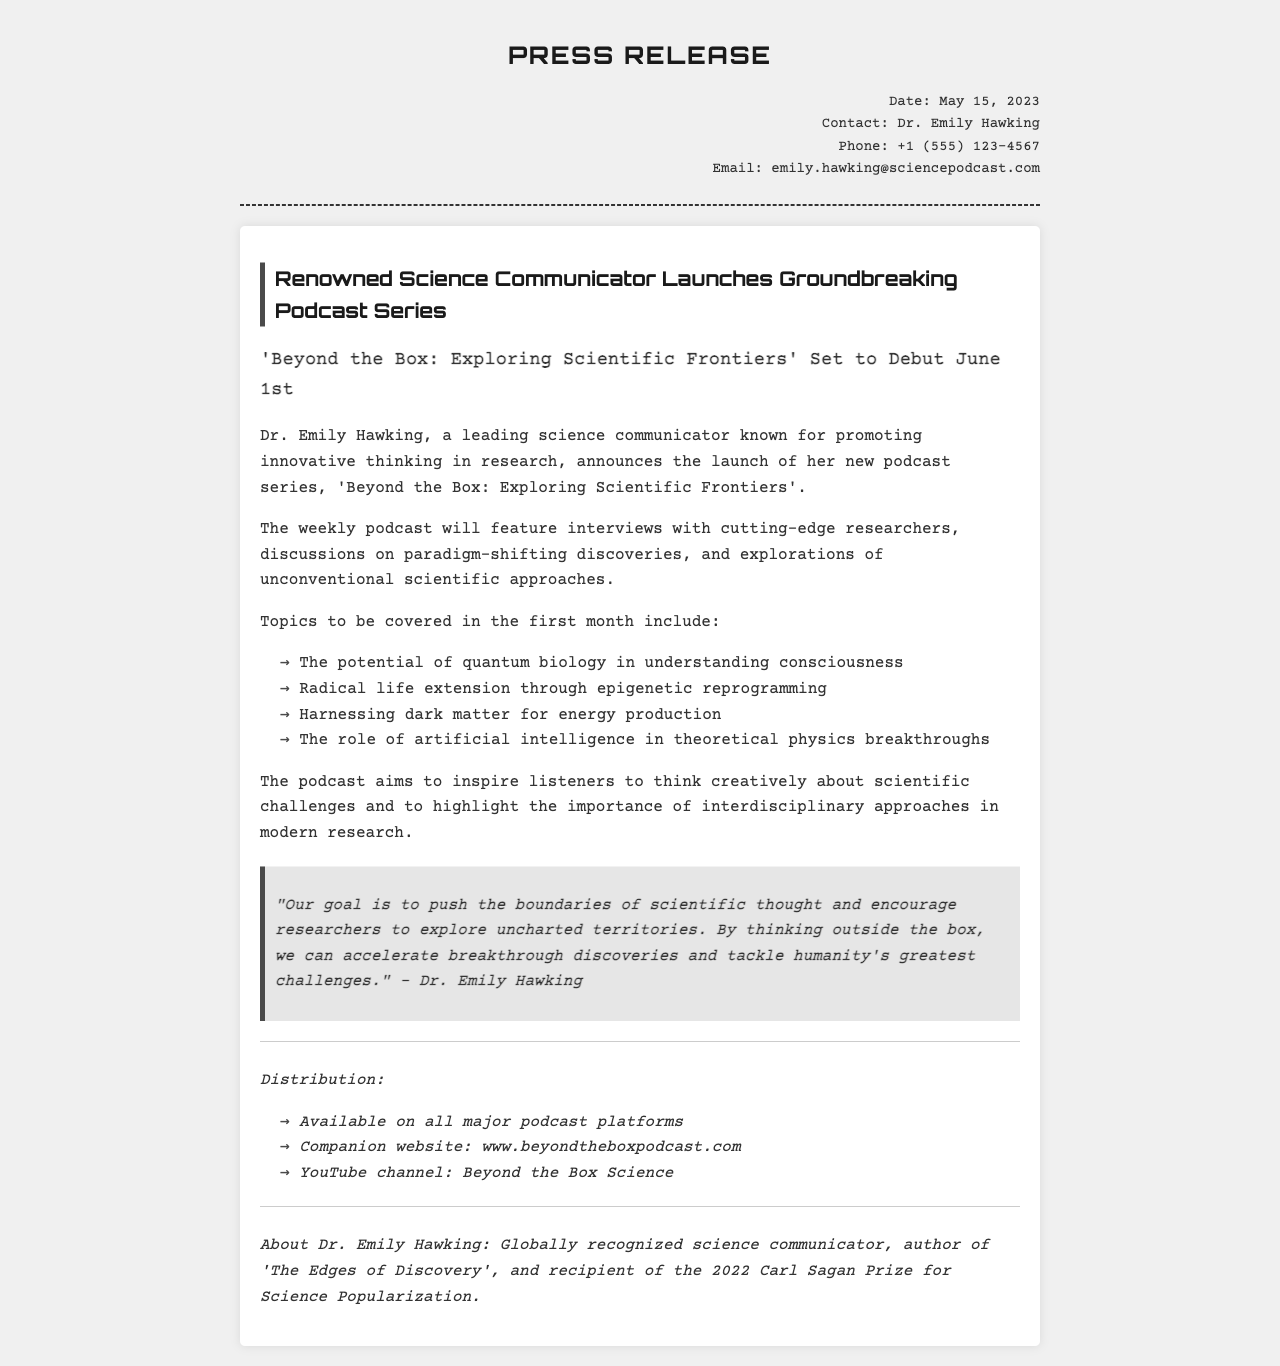What is the title of the podcast series? The title of the podcast series is mentioned as 'Beyond the Box: Exploring Scientific Frontiers'.
Answer: 'Beyond the Box: Exploring Scientific Frontiers' Who is the host of the podcast? The host, as stated in the document, is Dr. Emily Hawking.
Answer: Dr. Emily Hawking What is the launch date of the podcast? The launch date is specified in the document as June 1st.
Answer: June 1st How many topics will be covered in the first month? The document lists four topics to be covered in the first month of the podcast.
Answer: Four What is the goal of the podcast according to the host? The goal is described as pushing the boundaries of scientific thought and encouraging exploration of uncharted territories.
Answer: Push the boundaries of scientific thought On which platform will the podcast be available? The document mentions that the podcast will be available on all major podcast platforms.
Answer: All major podcast platforms What prize did Dr. Emily Hawking receive in 2022? The document states that she received the Carl Sagan Prize for Science Popularization in 2022.
Answer: Carl Sagan Prize for Science Popularization What is the name of the companion website for the podcast? The name of the companion website is given as www.beyondtheboxpodcast.com.
Answer: www.beyondtheboxpodcast.com 